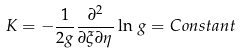Convert formula to latex. <formula><loc_0><loc_0><loc_500><loc_500>K = - \frac { 1 } { 2 g } \frac { \partial ^ { 2 } } { \partial \xi \partial \eta } \ln \, g = C o n s t a n t</formula> 